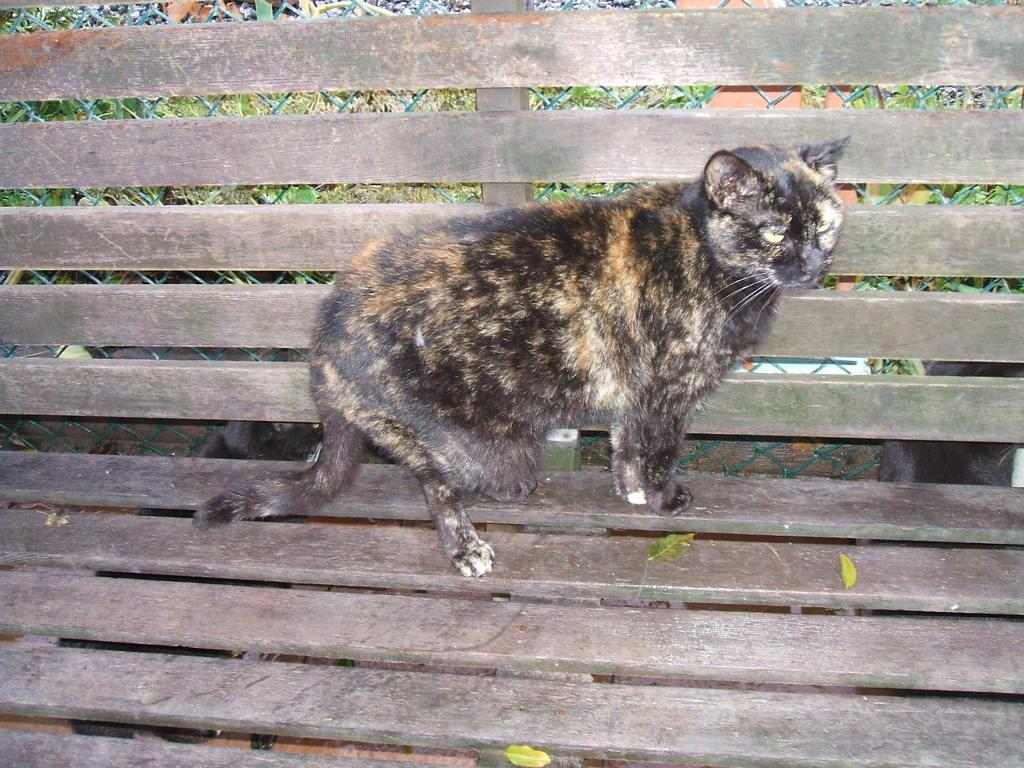What type of animal is on the bench in the image? There is a cat on a bench in the image. How many cats are visible in the image? There are three cats in total, with two more on the floor in the image. What type of carriage can be seen in the garden in the image? There is no carriage or garden present in the image; it features a bench and cats on the floor. 